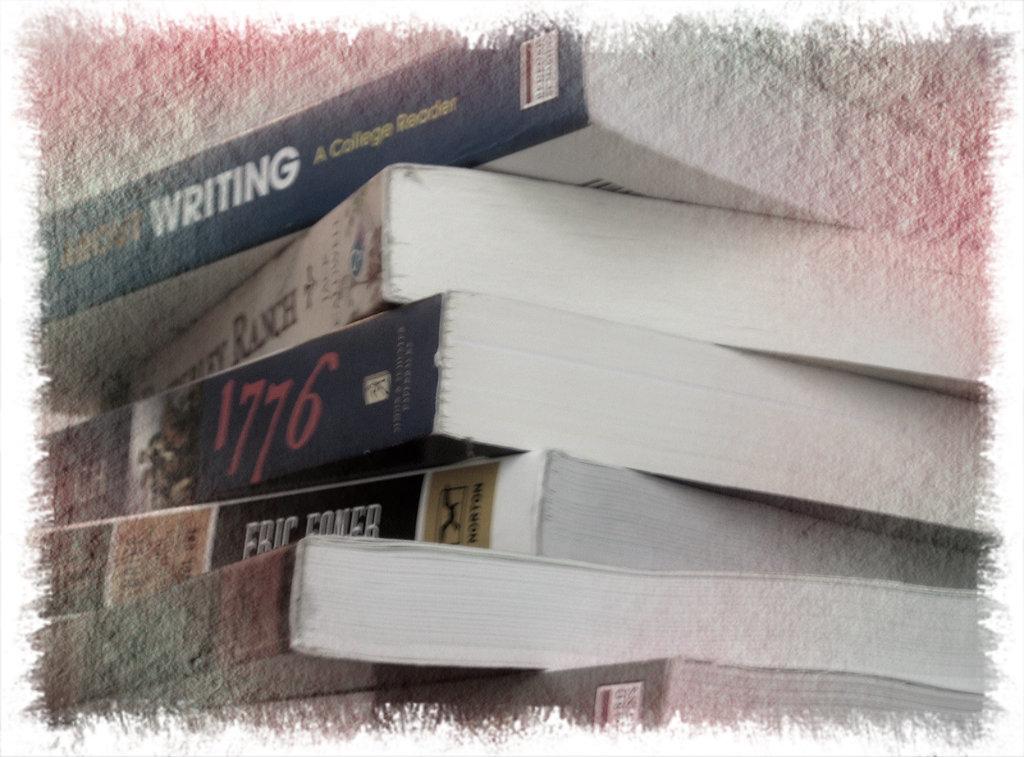Whats the title of the third book from the top?
Offer a very short reply. 1776. What type of "reader" is the top book?
Make the answer very short. College. 